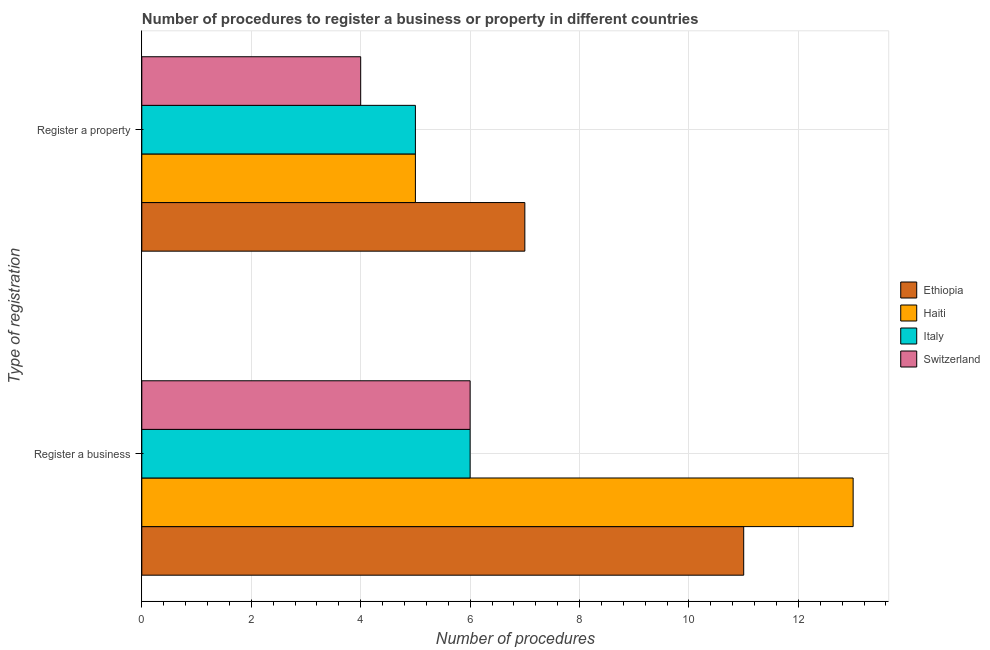Are the number of bars per tick equal to the number of legend labels?
Offer a very short reply. Yes. How many bars are there on the 2nd tick from the top?
Give a very brief answer. 4. What is the label of the 1st group of bars from the top?
Provide a short and direct response. Register a property. Across all countries, what is the maximum number of procedures to register a business?
Offer a very short reply. 13. In which country was the number of procedures to register a business maximum?
Your answer should be very brief. Haiti. In which country was the number of procedures to register a property minimum?
Provide a succinct answer. Switzerland. What is the total number of procedures to register a property in the graph?
Your answer should be compact. 21. What is the difference between the number of procedures to register a business in Ethiopia and that in Switzerland?
Provide a succinct answer. 5. What is the difference between the number of procedures to register a business and number of procedures to register a property in Haiti?
Provide a short and direct response. 8. In how many countries, is the number of procedures to register a business greater than 4 ?
Make the answer very short. 4. What is the ratio of the number of procedures to register a property in Switzerland to that in Ethiopia?
Ensure brevity in your answer.  0.57. In how many countries, is the number of procedures to register a business greater than the average number of procedures to register a business taken over all countries?
Your answer should be compact. 2. What does the 2nd bar from the top in Register a property represents?
Provide a succinct answer. Italy. What does the 2nd bar from the bottom in Register a property represents?
Ensure brevity in your answer.  Haiti. How many bars are there?
Provide a short and direct response. 8. What is the difference between two consecutive major ticks on the X-axis?
Keep it short and to the point. 2. Where does the legend appear in the graph?
Your answer should be compact. Center right. How many legend labels are there?
Ensure brevity in your answer.  4. How are the legend labels stacked?
Ensure brevity in your answer.  Vertical. What is the title of the graph?
Offer a terse response. Number of procedures to register a business or property in different countries. Does "Honduras" appear as one of the legend labels in the graph?
Keep it short and to the point. No. What is the label or title of the X-axis?
Provide a short and direct response. Number of procedures. What is the label or title of the Y-axis?
Keep it short and to the point. Type of registration. What is the Number of procedures in Haiti in Register a business?
Offer a terse response. 13. What is the Number of procedures of Ethiopia in Register a property?
Your answer should be compact. 7. What is the Number of procedures of Haiti in Register a property?
Offer a terse response. 5. What is the Number of procedures of Italy in Register a property?
Ensure brevity in your answer.  5. What is the Number of procedures in Switzerland in Register a property?
Ensure brevity in your answer.  4. Across all Type of registration, what is the maximum Number of procedures of Ethiopia?
Keep it short and to the point. 11. Across all Type of registration, what is the minimum Number of procedures of Switzerland?
Make the answer very short. 4. What is the total Number of procedures in Italy in the graph?
Your answer should be compact. 11. What is the difference between the Number of procedures in Haiti in Register a business and that in Register a property?
Make the answer very short. 8. What is the difference between the Number of procedures of Ethiopia in Register a business and the Number of procedures of Italy in Register a property?
Offer a very short reply. 6. What is the difference between the Number of procedures of Haiti in Register a business and the Number of procedures of Italy in Register a property?
Provide a short and direct response. 8. What is the difference between the Number of procedures in Haiti in Register a business and the Number of procedures in Switzerland in Register a property?
Provide a short and direct response. 9. What is the average Number of procedures of Ethiopia per Type of registration?
Provide a short and direct response. 9. What is the average Number of procedures in Italy per Type of registration?
Keep it short and to the point. 5.5. What is the average Number of procedures in Switzerland per Type of registration?
Offer a very short reply. 5. What is the difference between the Number of procedures of Ethiopia and Number of procedures of Haiti in Register a business?
Make the answer very short. -2. What is the difference between the Number of procedures in Ethiopia and Number of procedures in Italy in Register a business?
Your answer should be compact. 5. What is the difference between the Number of procedures in Ethiopia and Number of procedures in Switzerland in Register a business?
Provide a succinct answer. 5. What is the difference between the Number of procedures in Haiti and Number of procedures in Italy in Register a business?
Offer a terse response. 7. What is the difference between the Number of procedures of Haiti and Number of procedures of Switzerland in Register a business?
Your answer should be compact. 7. What is the difference between the Number of procedures of Ethiopia and Number of procedures of Switzerland in Register a property?
Make the answer very short. 3. What is the ratio of the Number of procedures in Ethiopia in Register a business to that in Register a property?
Offer a terse response. 1.57. What is the ratio of the Number of procedures of Italy in Register a business to that in Register a property?
Your answer should be very brief. 1.2. What is the ratio of the Number of procedures in Switzerland in Register a business to that in Register a property?
Give a very brief answer. 1.5. What is the difference between the highest and the second highest Number of procedures of Italy?
Make the answer very short. 1. What is the difference between the highest and the second highest Number of procedures in Switzerland?
Keep it short and to the point. 2. 